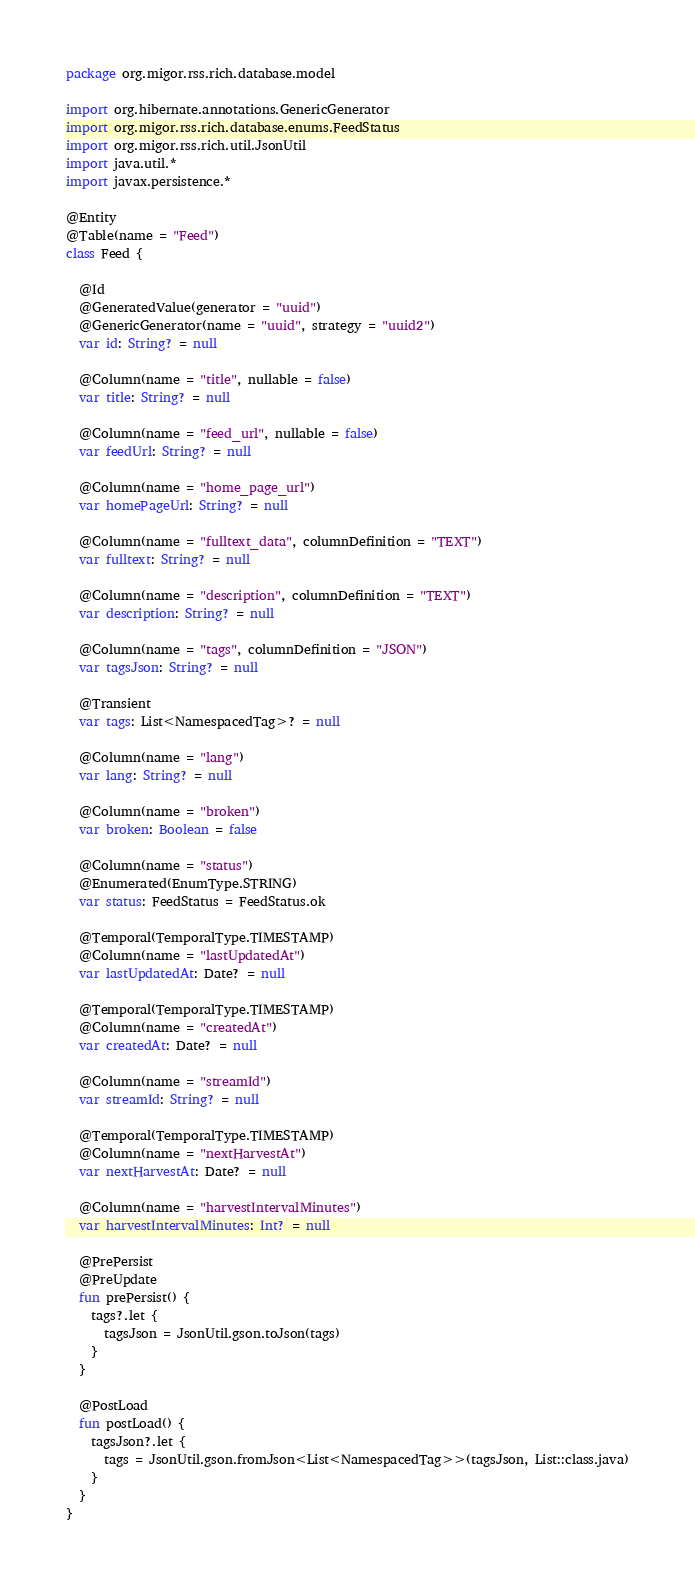<code> <loc_0><loc_0><loc_500><loc_500><_Kotlin_>package org.migor.rss.rich.database.model

import org.hibernate.annotations.GenericGenerator
import org.migor.rss.rich.database.enums.FeedStatus
import org.migor.rss.rich.util.JsonUtil
import java.util.*
import javax.persistence.*

@Entity
@Table(name = "Feed")
class Feed {

  @Id
  @GeneratedValue(generator = "uuid")
  @GenericGenerator(name = "uuid", strategy = "uuid2")
  var id: String? = null

  @Column(name = "title", nullable = false)
  var title: String? = null

  @Column(name = "feed_url", nullable = false)
  var feedUrl: String? = null

  @Column(name = "home_page_url")
  var homePageUrl: String? = null

  @Column(name = "fulltext_data", columnDefinition = "TEXT")
  var fulltext: String? = null

  @Column(name = "description", columnDefinition = "TEXT")
  var description: String? = null

  @Column(name = "tags", columnDefinition = "JSON")
  var tagsJson: String? = null

  @Transient
  var tags: List<NamespacedTag>? = null

  @Column(name = "lang")
  var lang: String? = null

  @Column(name = "broken")
  var broken: Boolean = false

  @Column(name = "status")
  @Enumerated(EnumType.STRING)
  var status: FeedStatus = FeedStatus.ok

  @Temporal(TemporalType.TIMESTAMP)
  @Column(name = "lastUpdatedAt")
  var lastUpdatedAt: Date? = null

  @Temporal(TemporalType.TIMESTAMP)
  @Column(name = "createdAt")
  var createdAt: Date? = null

  @Column(name = "streamId")
  var streamId: String? = null

  @Temporal(TemporalType.TIMESTAMP)
  @Column(name = "nextHarvestAt")
  var nextHarvestAt: Date? = null

  @Column(name = "harvestIntervalMinutes")
  var harvestIntervalMinutes: Int? = null

  @PrePersist
  @PreUpdate
  fun prePersist() {
    tags?.let {
      tagsJson = JsonUtil.gson.toJson(tags)
    }
  }

  @PostLoad
  fun postLoad() {
    tagsJson?.let {
      tags = JsonUtil.gson.fromJson<List<NamespacedTag>>(tagsJson, List::class.java)
    }
  }
}
</code> 